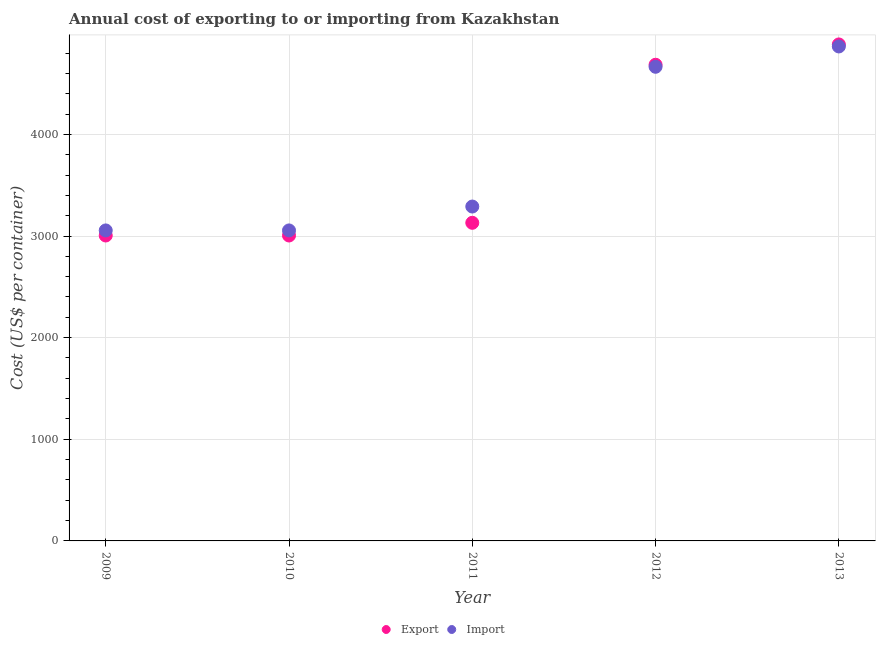How many different coloured dotlines are there?
Your answer should be very brief. 2. Is the number of dotlines equal to the number of legend labels?
Offer a very short reply. Yes. What is the import cost in 2011?
Offer a terse response. 3290. Across all years, what is the maximum import cost?
Your answer should be compact. 4865. Across all years, what is the minimum import cost?
Make the answer very short. 3055. In which year was the export cost maximum?
Provide a short and direct response. 2013. In which year was the export cost minimum?
Keep it short and to the point. 2009. What is the total import cost in the graph?
Give a very brief answer. 1.89e+04. What is the difference between the export cost in 2009 and that in 2013?
Make the answer very short. -1880. What is the difference between the import cost in 2013 and the export cost in 2012?
Provide a succinct answer. 180. What is the average export cost per year?
Offer a very short reply. 3742. In the year 2012, what is the difference between the export cost and import cost?
Provide a succinct answer. 20. In how many years, is the export cost greater than 2400 US$?
Your answer should be very brief. 5. What is the ratio of the import cost in 2009 to that in 2012?
Provide a short and direct response. 0.65. Is the import cost in 2010 less than that in 2011?
Your answer should be very brief. Yes. Is the difference between the export cost in 2010 and 2011 greater than the difference between the import cost in 2010 and 2011?
Your answer should be very brief. Yes. What is the difference between the highest and the lowest import cost?
Your answer should be compact. 1810. Is the export cost strictly greater than the import cost over the years?
Make the answer very short. No. Is the import cost strictly less than the export cost over the years?
Ensure brevity in your answer.  No. How many dotlines are there?
Offer a very short reply. 2. How many years are there in the graph?
Your answer should be compact. 5. How many legend labels are there?
Keep it short and to the point. 2. What is the title of the graph?
Offer a terse response. Annual cost of exporting to or importing from Kazakhstan. What is the label or title of the X-axis?
Your answer should be compact. Year. What is the label or title of the Y-axis?
Your response must be concise. Cost (US$ per container). What is the Cost (US$ per container) of Export in 2009?
Offer a very short reply. 3005. What is the Cost (US$ per container) of Import in 2009?
Make the answer very short. 3055. What is the Cost (US$ per container) in Export in 2010?
Offer a terse response. 3005. What is the Cost (US$ per container) of Import in 2010?
Give a very brief answer. 3055. What is the Cost (US$ per container) in Export in 2011?
Provide a succinct answer. 3130. What is the Cost (US$ per container) in Import in 2011?
Provide a short and direct response. 3290. What is the Cost (US$ per container) of Export in 2012?
Ensure brevity in your answer.  4685. What is the Cost (US$ per container) of Import in 2012?
Offer a terse response. 4665. What is the Cost (US$ per container) of Export in 2013?
Keep it short and to the point. 4885. What is the Cost (US$ per container) in Import in 2013?
Give a very brief answer. 4865. Across all years, what is the maximum Cost (US$ per container) in Export?
Provide a short and direct response. 4885. Across all years, what is the maximum Cost (US$ per container) of Import?
Provide a short and direct response. 4865. Across all years, what is the minimum Cost (US$ per container) in Export?
Give a very brief answer. 3005. Across all years, what is the minimum Cost (US$ per container) of Import?
Provide a short and direct response. 3055. What is the total Cost (US$ per container) of Export in the graph?
Offer a terse response. 1.87e+04. What is the total Cost (US$ per container) of Import in the graph?
Offer a terse response. 1.89e+04. What is the difference between the Cost (US$ per container) in Import in 2009 and that in 2010?
Offer a very short reply. 0. What is the difference between the Cost (US$ per container) of Export in 2009 and that in 2011?
Offer a very short reply. -125. What is the difference between the Cost (US$ per container) of Import in 2009 and that in 2011?
Ensure brevity in your answer.  -235. What is the difference between the Cost (US$ per container) of Export in 2009 and that in 2012?
Keep it short and to the point. -1680. What is the difference between the Cost (US$ per container) in Import in 2009 and that in 2012?
Ensure brevity in your answer.  -1610. What is the difference between the Cost (US$ per container) in Export in 2009 and that in 2013?
Keep it short and to the point. -1880. What is the difference between the Cost (US$ per container) in Import in 2009 and that in 2013?
Provide a short and direct response. -1810. What is the difference between the Cost (US$ per container) of Export in 2010 and that in 2011?
Ensure brevity in your answer.  -125. What is the difference between the Cost (US$ per container) of Import in 2010 and that in 2011?
Provide a short and direct response. -235. What is the difference between the Cost (US$ per container) in Export in 2010 and that in 2012?
Provide a short and direct response. -1680. What is the difference between the Cost (US$ per container) in Import in 2010 and that in 2012?
Offer a terse response. -1610. What is the difference between the Cost (US$ per container) of Export in 2010 and that in 2013?
Offer a very short reply. -1880. What is the difference between the Cost (US$ per container) of Import in 2010 and that in 2013?
Keep it short and to the point. -1810. What is the difference between the Cost (US$ per container) of Export in 2011 and that in 2012?
Offer a terse response. -1555. What is the difference between the Cost (US$ per container) of Import in 2011 and that in 2012?
Offer a very short reply. -1375. What is the difference between the Cost (US$ per container) of Export in 2011 and that in 2013?
Your response must be concise. -1755. What is the difference between the Cost (US$ per container) of Import in 2011 and that in 2013?
Ensure brevity in your answer.  -1575. What is the difference between the Cost (US$ per container) in Export in 2012 and that in 2013?
Provide a succinct answer. -200. What is the difference between the Cost (US$ per container) in Import in 2012 and that in 2013?
Offer a terse response. -200. What is the difference between the Cost (US$ per container) in Export in 2009 and the Cost (US$ per container) in Import in 2010?
Your answer should be very brief. -50. What is the difference between the Cost (US$ per container) in Export in 2009 and the Cost (US$ per container) in Import in 2011?
Ensure brevity in your answer.  -285. What is the difference between the Cost (US$ per container) in Export in 2009 and the Cost (US$ per container) in Import in 2012?
Make the answer very short. -1660. What is the difference between the Cost (US$ per container) in Export in 2009 and the Cost (US$ per container) in Import in 2013?
Your answer should be very brief. -1860. What is the difference between the Cost (US$ per container) in Export in 2010 and the Cost (US$ per container) in Import in 2011?
Your answer should be compact. -285. What is the difference between the Cost (US$ per container) in Export in 2010 and the Cost (US$ per container) in Import in 2012?
Provide a succinct answer. -1660. What is the difference between the Cost (US$ per container) in Export in 2010 and the Cost (US$ per container) in Import in 2013?
Give a very brief answer. -1860. What is the difference between the Cost (US$ per container) of Export in 2011 and the Cost (US$ per container) of Import in 2012?
Ensure brevity in your answer.  -1535. What is the difference between the Cost (US$ per container) of Export in 2011 and the Cost (US$ per container) of Import in 2013?
Your answer should be compact. -1735. What is the difference between the Cost (US$ per container) in Export in 2012 and the Cost (US$ per container) in Import in 2013?
Keep it short and to the point. -180. What is the average Cost (US$ per container) of Export per year?
Ensure brevity in your answer.  3742. What is the average Cost (US$ per container) in Import per year?
Ensure brevity in your answer.  3786. In the year 2010, what is the difference between the Cost (US$ per container) in Export and Cost (US$ per container) in Import?
Ensure brevity in your answer.  -50. In the year 2011, what is the difference between the Cost (US$ per container) of Export and Cost (US$ per container) of Import?
Make the answer very short. -160. What is the ratio of the Cost (US$ per container) of Export in 2009 to that in 2010?
Ensure brevity in your answer.  1. What is the ratio of the Cost (US$ per container) in Import in 2009 to that in 2010?
Provide a short and direct response. 1. What is the ratio of the Cost (US$ per container) in Export in 2009 to that in 2011?
Your response must be concise. 0.96. What is the ratio of the Cost (US$ per container) of Import in 2009 to that in 2011?
Give a very brief answer. 0.93. What is the ratio of the Cost (US$ per container) of Export in 2009 to that in 2012?
Your answer should be very brief. 0.64. What is the ratio of the Cost (US$ per container) in Import in 2009 to that in 2012?
Provide a succinct answer. 0.65. What is the ratio of the Cost (US$ per container) of Export in 2009 to that in 2013?
Provide a succinct answer. 0.62. What is the ratio of the Cost (US$ per container) in Import in 2009 to that in 2013?
Provide a short and direct response. 0.63. What is the ratio of the Cost (US$ per container) of Export in 2010 to that in 2011?
Your answer should be compact. 0.96. What is the ratio of the Cost (US$ per container) in Import in 2010 to that in 2011?
Give a very brief answer. 0.93. What is the ratio of the Cost (US$ per container) in Export in 2010 to that in 2012?
Your response must be concise. 0.64. What is the ratio of the Cost (US$ per container) in Import in 2010 to that in 2012?
Keep it short and to the point. 0.65. What is the ratio of the Cost (US$ per container) in Export in 2010 to that in 2013?
Keep it short and to the point. 0.62. What is the ratio of the Cost (US$ per container) of Import in 2010 to that in 2013?
Offer a terse response. 0.63. What is the ratio of the Cost (US$ per container) in Export in 2011 to that in 2012?
Provide a succinct answer. 0.67. What is the ratio of the Cost (US$ per container) of Import in 2011 to that in 2012?
Give a very brief answer. 0.71. What is the ratio of the Cost (US$ per container) of Export in 2011 to that in 2013?
Keep it short and to the point. 0.64. What is the ratio of the Cost (US$ per container) in Import in 2011 to that in 2013?
Offer a terse response. 0.68. What is the ratio of the Cost (US$ per container) of Export in 2012 to that in 2013?
Offer a very short reply. 0.96. What is the ratio of the Cost (US$ per container) of Import in 2012 to that in 2013?
Offer a very short reply. 0.96. What is the difference between the highest and the second highest Cost (US$ per container) of Import?
Your response must be concise. 200. What is the difference between the highest and the lowest Cost (US$ per container) in Export?
Your answer should be very brief. 1880. What is the difference between the highest and the lowest Cost (US$ per container) of Import?
Make the answer very short. 1810. 